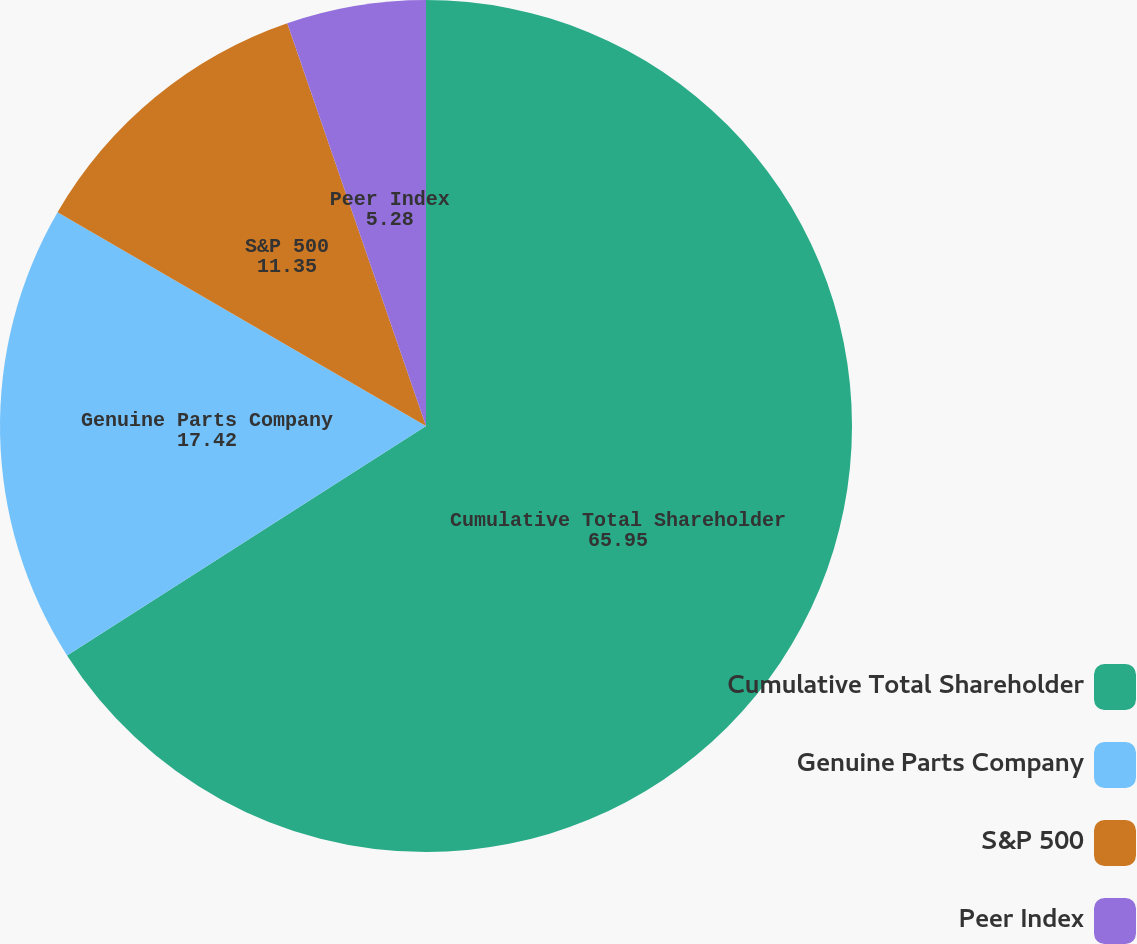Convert chart. <chart><loc_0><loc_0><loc_500><loc_500><pie_chart><fcel>Cumulative Total Shareholder<fcel>Genuine Parts Company<fcel>S&P 500<fcel>Peer Index<nl><fcel>65.95%<fcel>17.42%<fcel>11.35%<fcel>5.28%<nl></chart> 